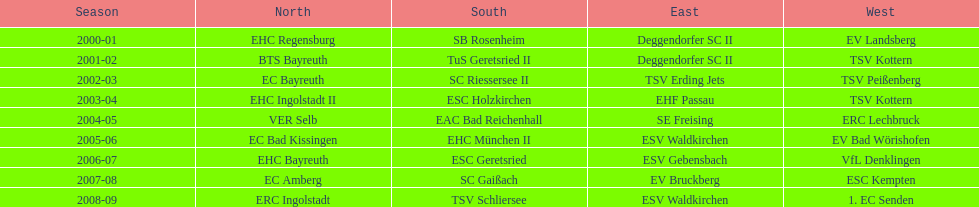Which name appears more often, kottern or bayreuth? Bayreuth. 